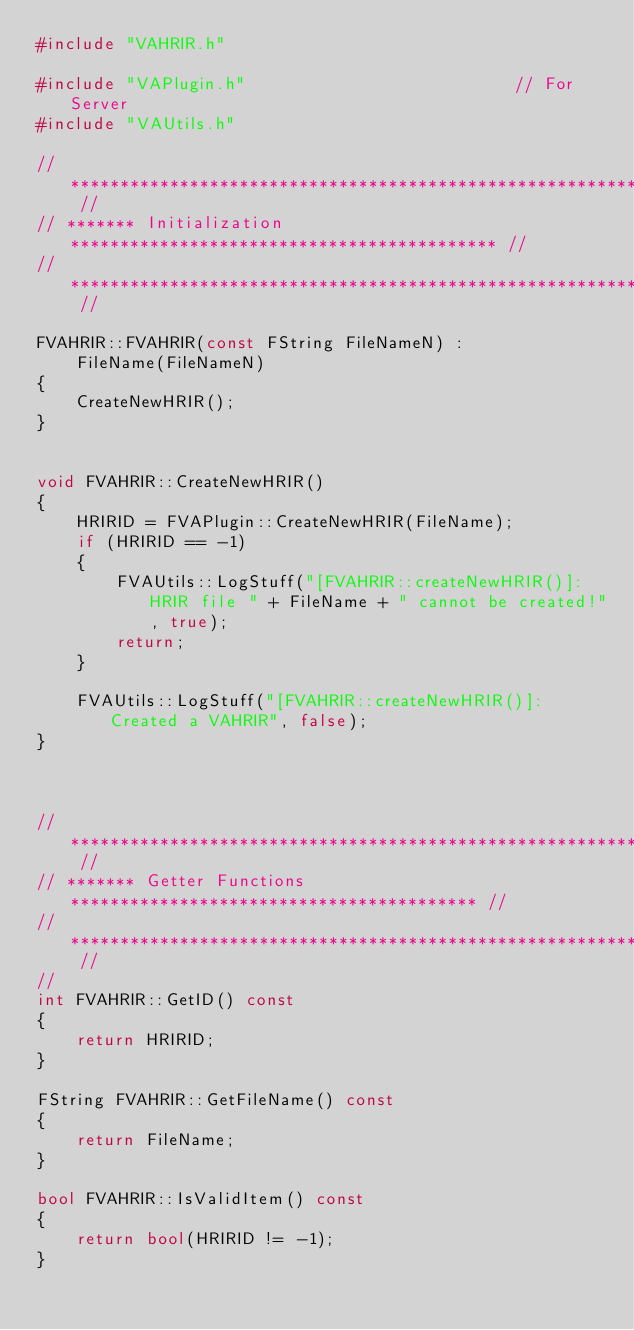Convert code to text. <code><loc_0><loc_0><loc_500><loc_500><_C++_>#include "VAHRIR.h"

#include "VAPlugin.h"							// For Server
#include "VAUtils.h"			

// ****************************************************************** // 
// ******* Initialization ******************************************* //
// ****************************************************************** //

FVAHRIR::FVAHRIR(const FString FileNameN) :
	FileName(FileNameN)
{
	CreateNewHRIR();
}


void FVAHRIR::CreateNewHRIR()
{
	HRIRID = FVAPlugin::CreateNewHRIR(FileName);
	if (HRIRID == -1)
	{
		FVAUtils::LogStuff("[FVAHRIR::createNewHRIR()]: HRIR file " + FileName + " cannot be created!", true);
		return;
	}

	FVAUtils::LogStuff("[FVAHRIR::createNewHRIR()]: Created a VAHRIR", false);
}



// ****************************************************************** // 
// ******* Getter Functions ***************************************** //
// ****************************************************************** //
// 
int FVAHRIR::GetID() const
{
	return HRIRID;
}

FString FVAHRIR::GetFileName() const
{
	return FileName;
}

bool FVAHRIR::IsValidItem() const
{
	return bool(HRIRID != -1);
}

</code> 